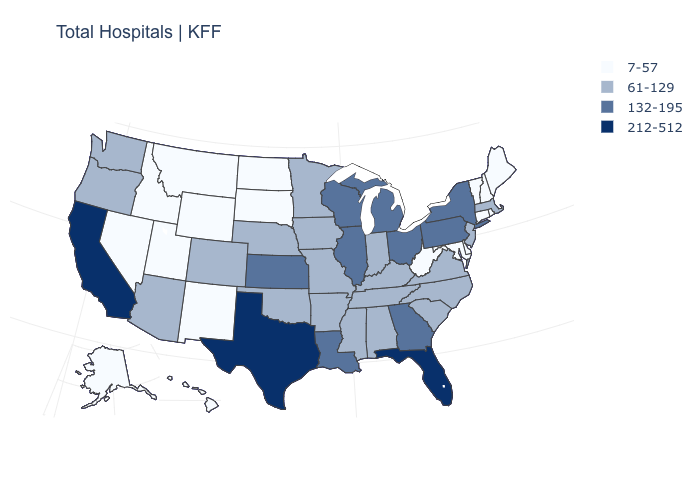Name the states that have a value in the range 7-57?
Short answer required. Alaska, Connecticut, Delaware, Hawaii, Idaho, Maine, Maryland, Montana, Nevada, New Hampshire, New Mexico, North Dakota, Rhode Island, South Dakota, Utah, Vermont, West Virginia, Wyoming. What is the value of New York?
Keep it brief. 132-195. What is the highest value in the MidWest ?
Quick response, please. 132-195. Name the states that have a value in the range 132-195?
Answer briefly. Georgia, Illinois, Kansas, Louisiana, Michigan, New York, Ohio, Pennsylvania, Wisconsin. Does Florida have the highest value in the USA?
Keep it brief. Yes. Does Texas have the highest value in the USA?
Concise answer only. Yes. Name the states that have a value in the range 61-129?
Write a very short answer. Alabama, Arizona, Arkansas, Colorado, Indiana, Iowa, Kentucky, Massachusetts, Minnesota, Mississippi, Missouri, Nebraska, New Jersey, North Carolina, Oklahoma, Oregon, South Carolina, Tennessee, Virginia, Washington. What is the lowest value in states that border Kansas?
Short answer required. 61-129. What is the value of Tennessee?
Concise answer only. 61-129. What is the lowest value in the USA?
Concise answer only. 7-57. Which states have the lowest value in the USA?
Short answer required. Alaska, Connecticut, Delaware, Hawaii, Idaho, Maine, Maryland, Montana, Nevada, New Hampshire, New Mexico, North Dakota, Rhode Island, South Dakota, Utah, Vermont, West Virginia, Wyoming. Does Texas have the highest value in the USA?
Concise answer only. Yes. What is the lowest value in the MidWest?
Concise answer only. 7-57. What is the value of Florida?
Write a very short answer. 212-512. Which states hav the highest value in the West?
Keep it brief. California. 